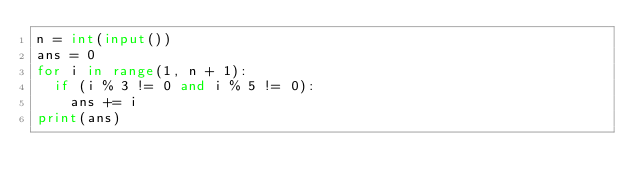<code> <loc_0><loc_0><loc_500><loc_500><_Python_>n = int(input())
ans = 0
for i in range(1, n + 1):
  if (i % 3 != 0 and i % 5 != 0):
    ans += i
print(ans)</code> 